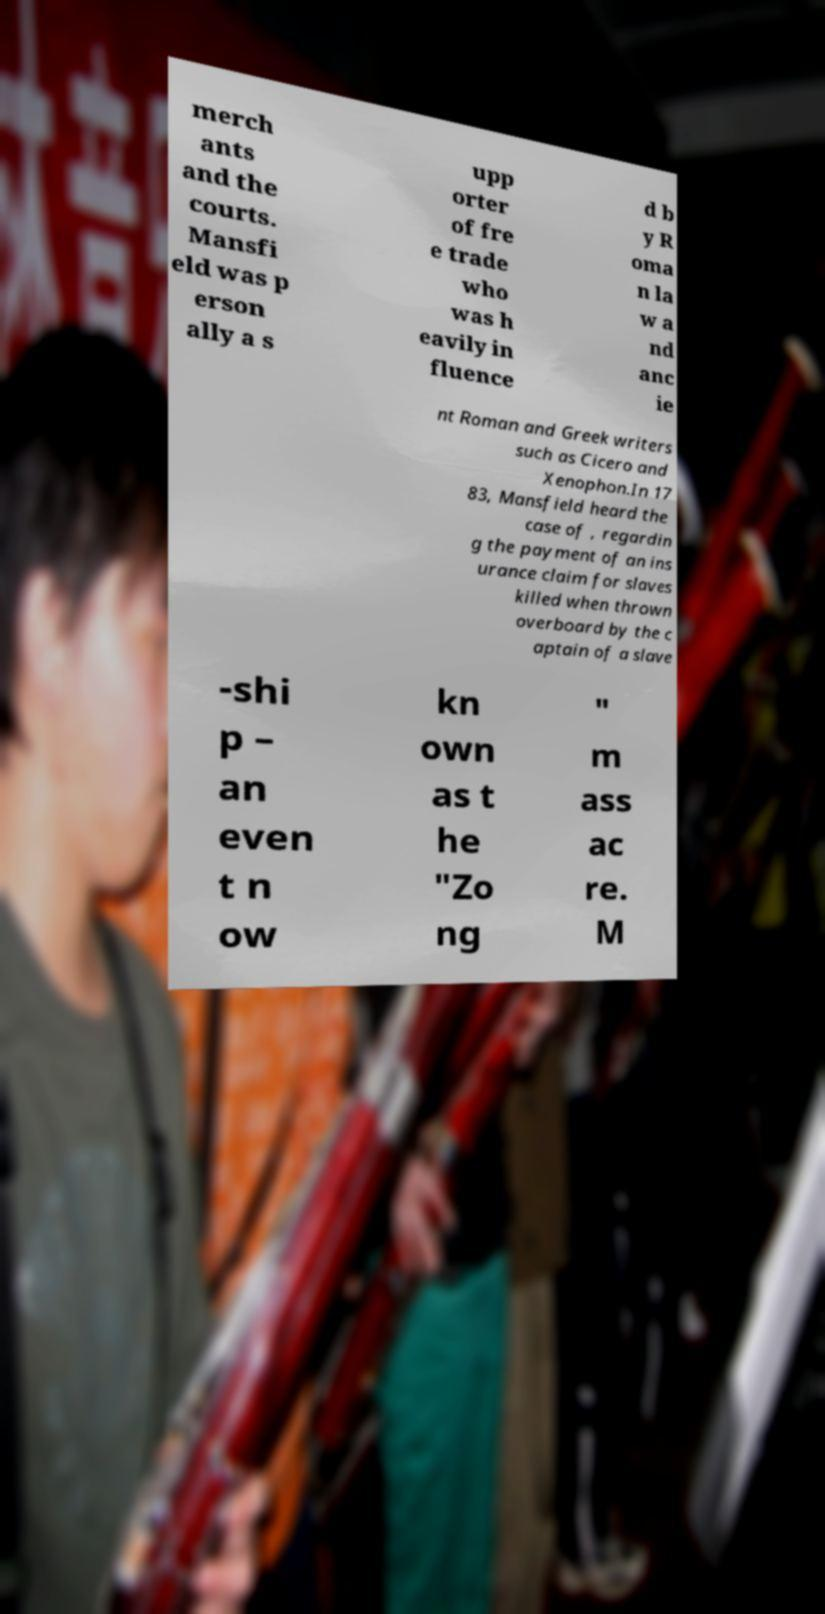Please read and relay the text visible in this image. What does it say? merch ants and the courts. Mansfi eld was p erson ally a s upp orter of fre e trade who was h eavily in fluence d b y R oma n la w a nd anc ie nt Roman and Greek writers such as Cicero and Xenophon.In 17 83, Mansfield heard the case of , regardin g the payment of an ins urance claim for slaves killed when thrown overboard by the c aptain of a slave -shi p – an even t n ow kn own as t he "Zo ng " m ass ac re. M 